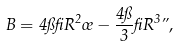<formula> <loc_0><loc_0><loc_500><loc_500>B = 4 \pi \beta R ^ { 2 } \sigma - \frac { 4 \pi } { 3 } \beta R ^ { 3 } \varepsilon ,</formula> 